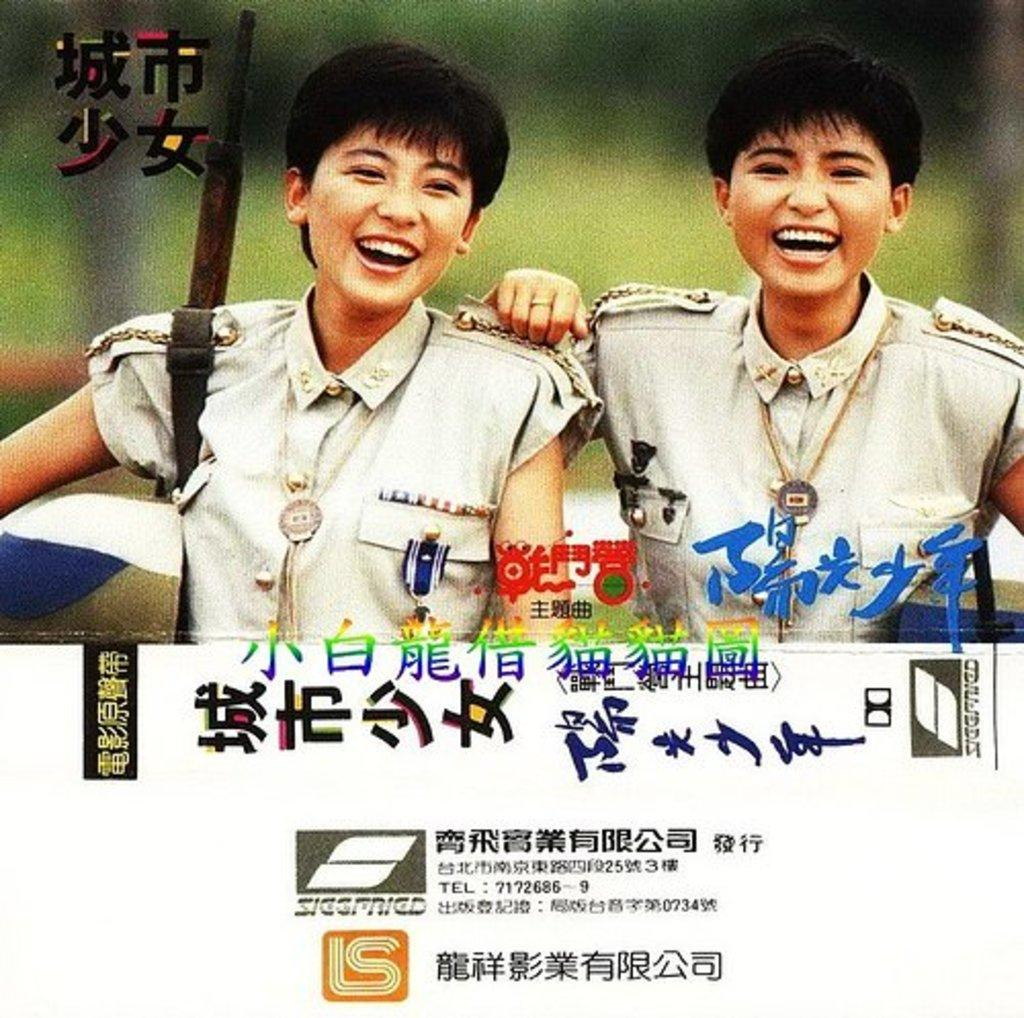What type of visual is depicted in the image? The image appears to be a poster. How many people are in the image? There are two persons in the image. What are the two persons wearing? The two persons are wearing the same dress. Is there any text associated with the image of the two persons? Yes, there is text written under the image of the two persons. How many centimeters tall is the arch in the image? There is no arch present in the image. What type of land can be seen in the background of the image? The image does not show any land or background; it is a poster featuring two persons wearing the same dress with text underneath. 